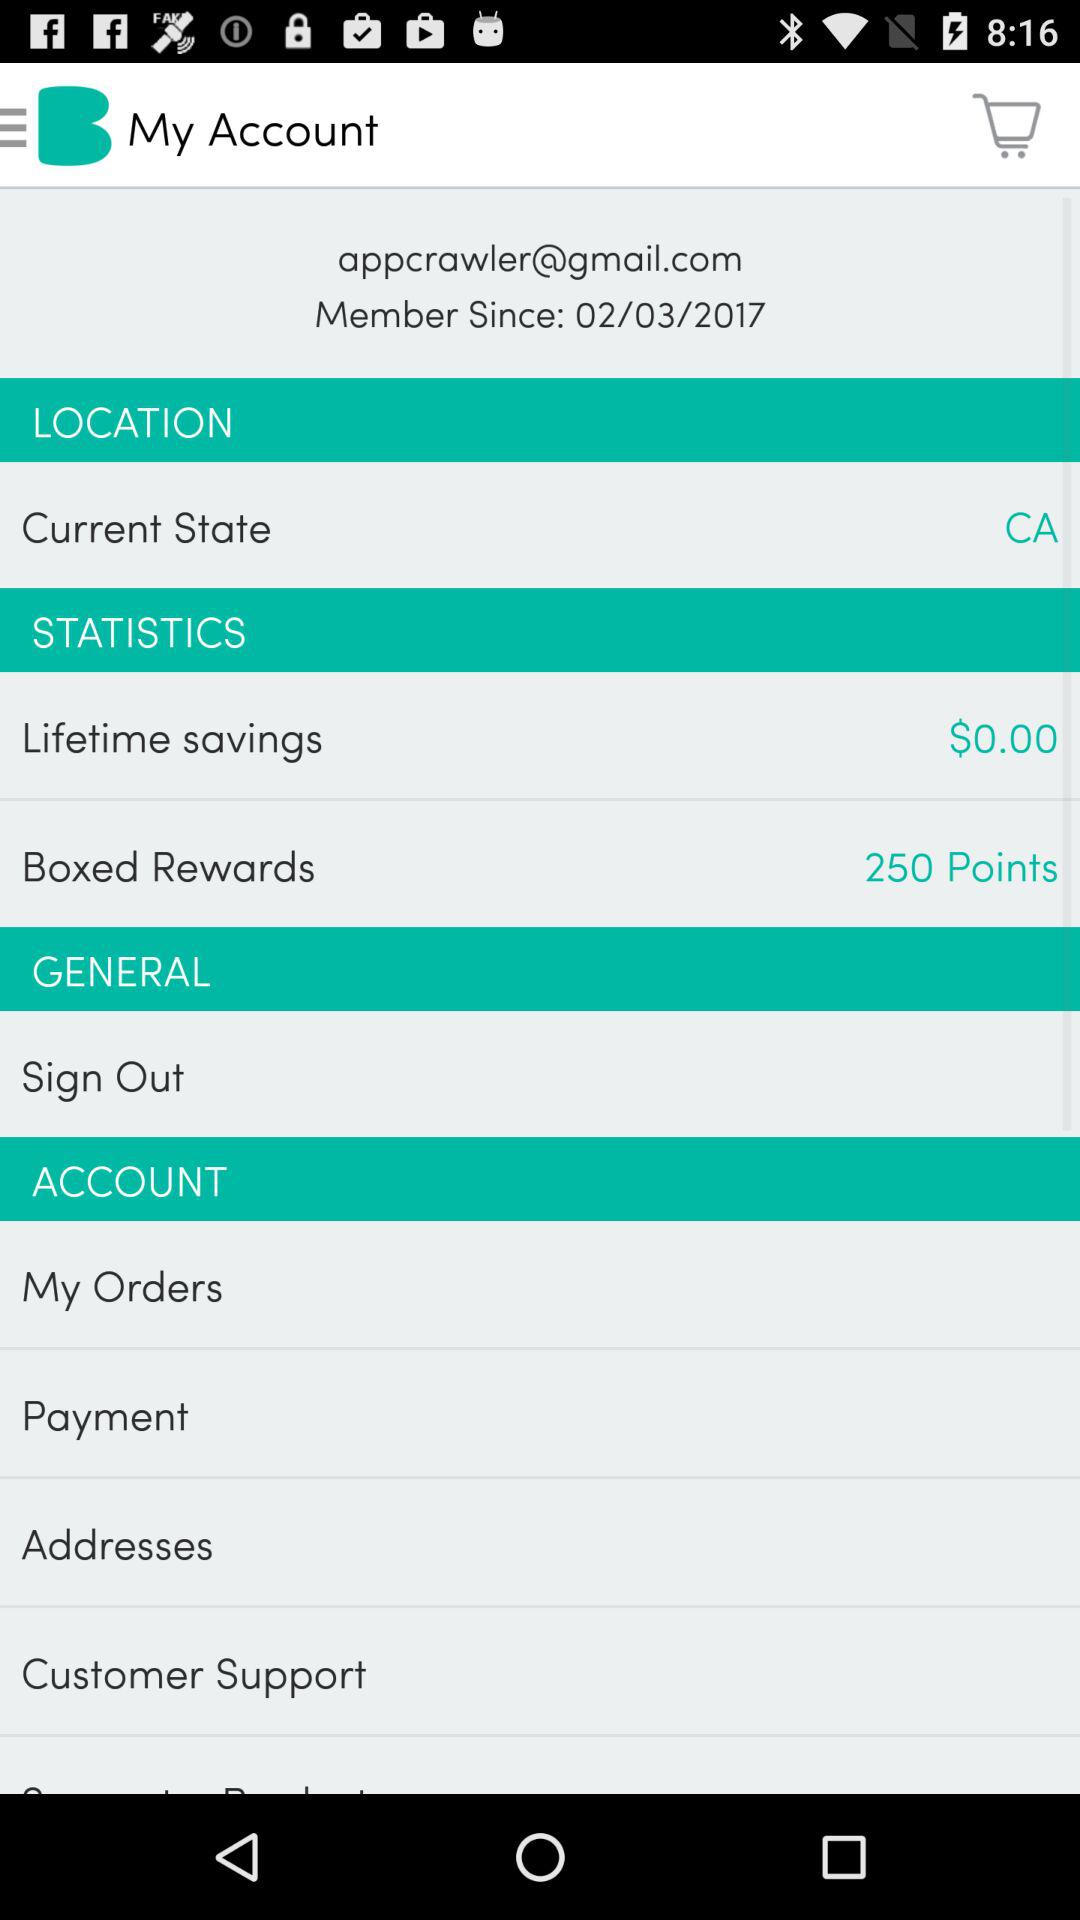How much money do I have in lifetime savings?
Answer the question using a single word or phrase. $0.00 